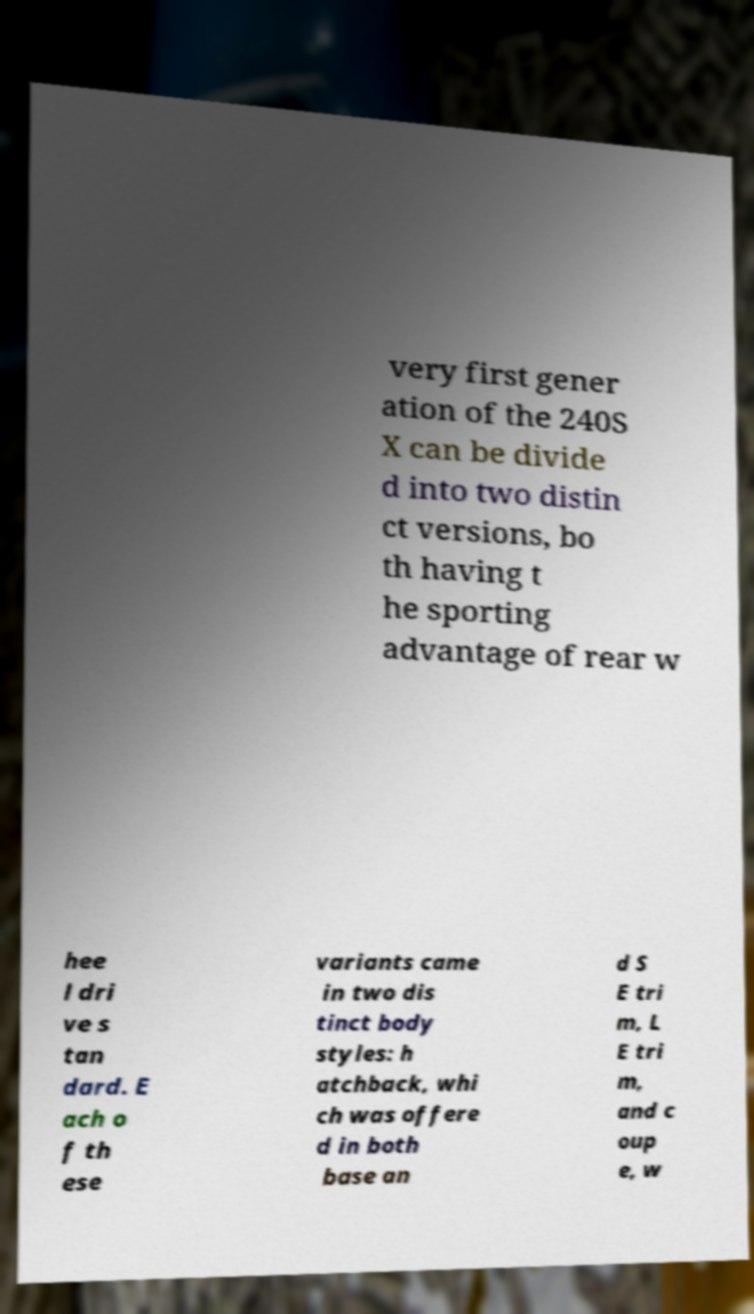I need the written content from this picture converted into text. Can you do that? very first gener ation of the 240S X can be divide d into two distin ct versions, bo th having t he sporting advantage of rear w hee l dri ve s tan dard. E ach o f th ese variants came in two dis tinct body styles: h atchback, whi ch was offere d in both base an d S E tri m, L E tri m, and c oup e, w 